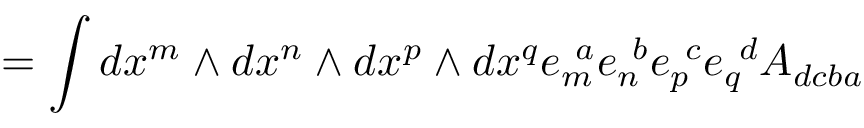<formula> <loc_0><loc_0><loc_500><loc_500>= \int d x ^ { m } \wedge d x ^ { n } \wedge d x ^ { p } \wedge d x ^ { q } e _ { m } ^ { \ a } e _ { n } ^ { \ b } e _ { p } ^ { \ c } e _ { q } ^ { \ d } A _ { d c b a }</formula> 